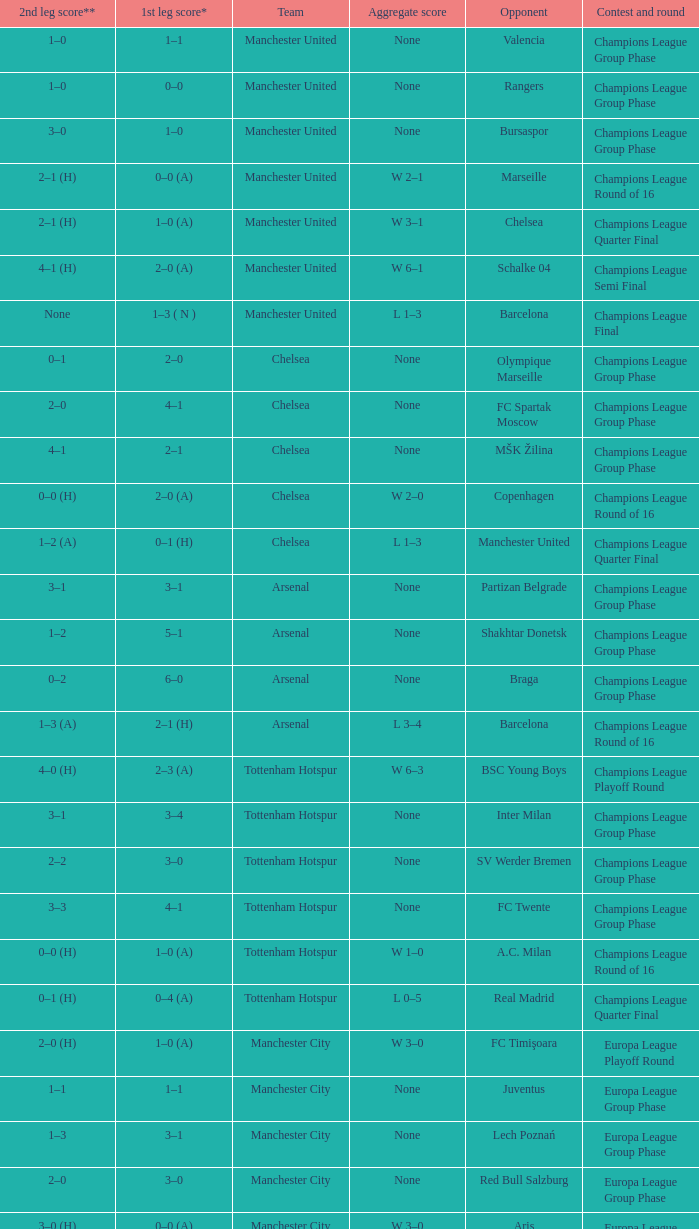In the opening leg of the match between liverpool and steaua bucureşti, how many goals were scored by each team? 4–1. 